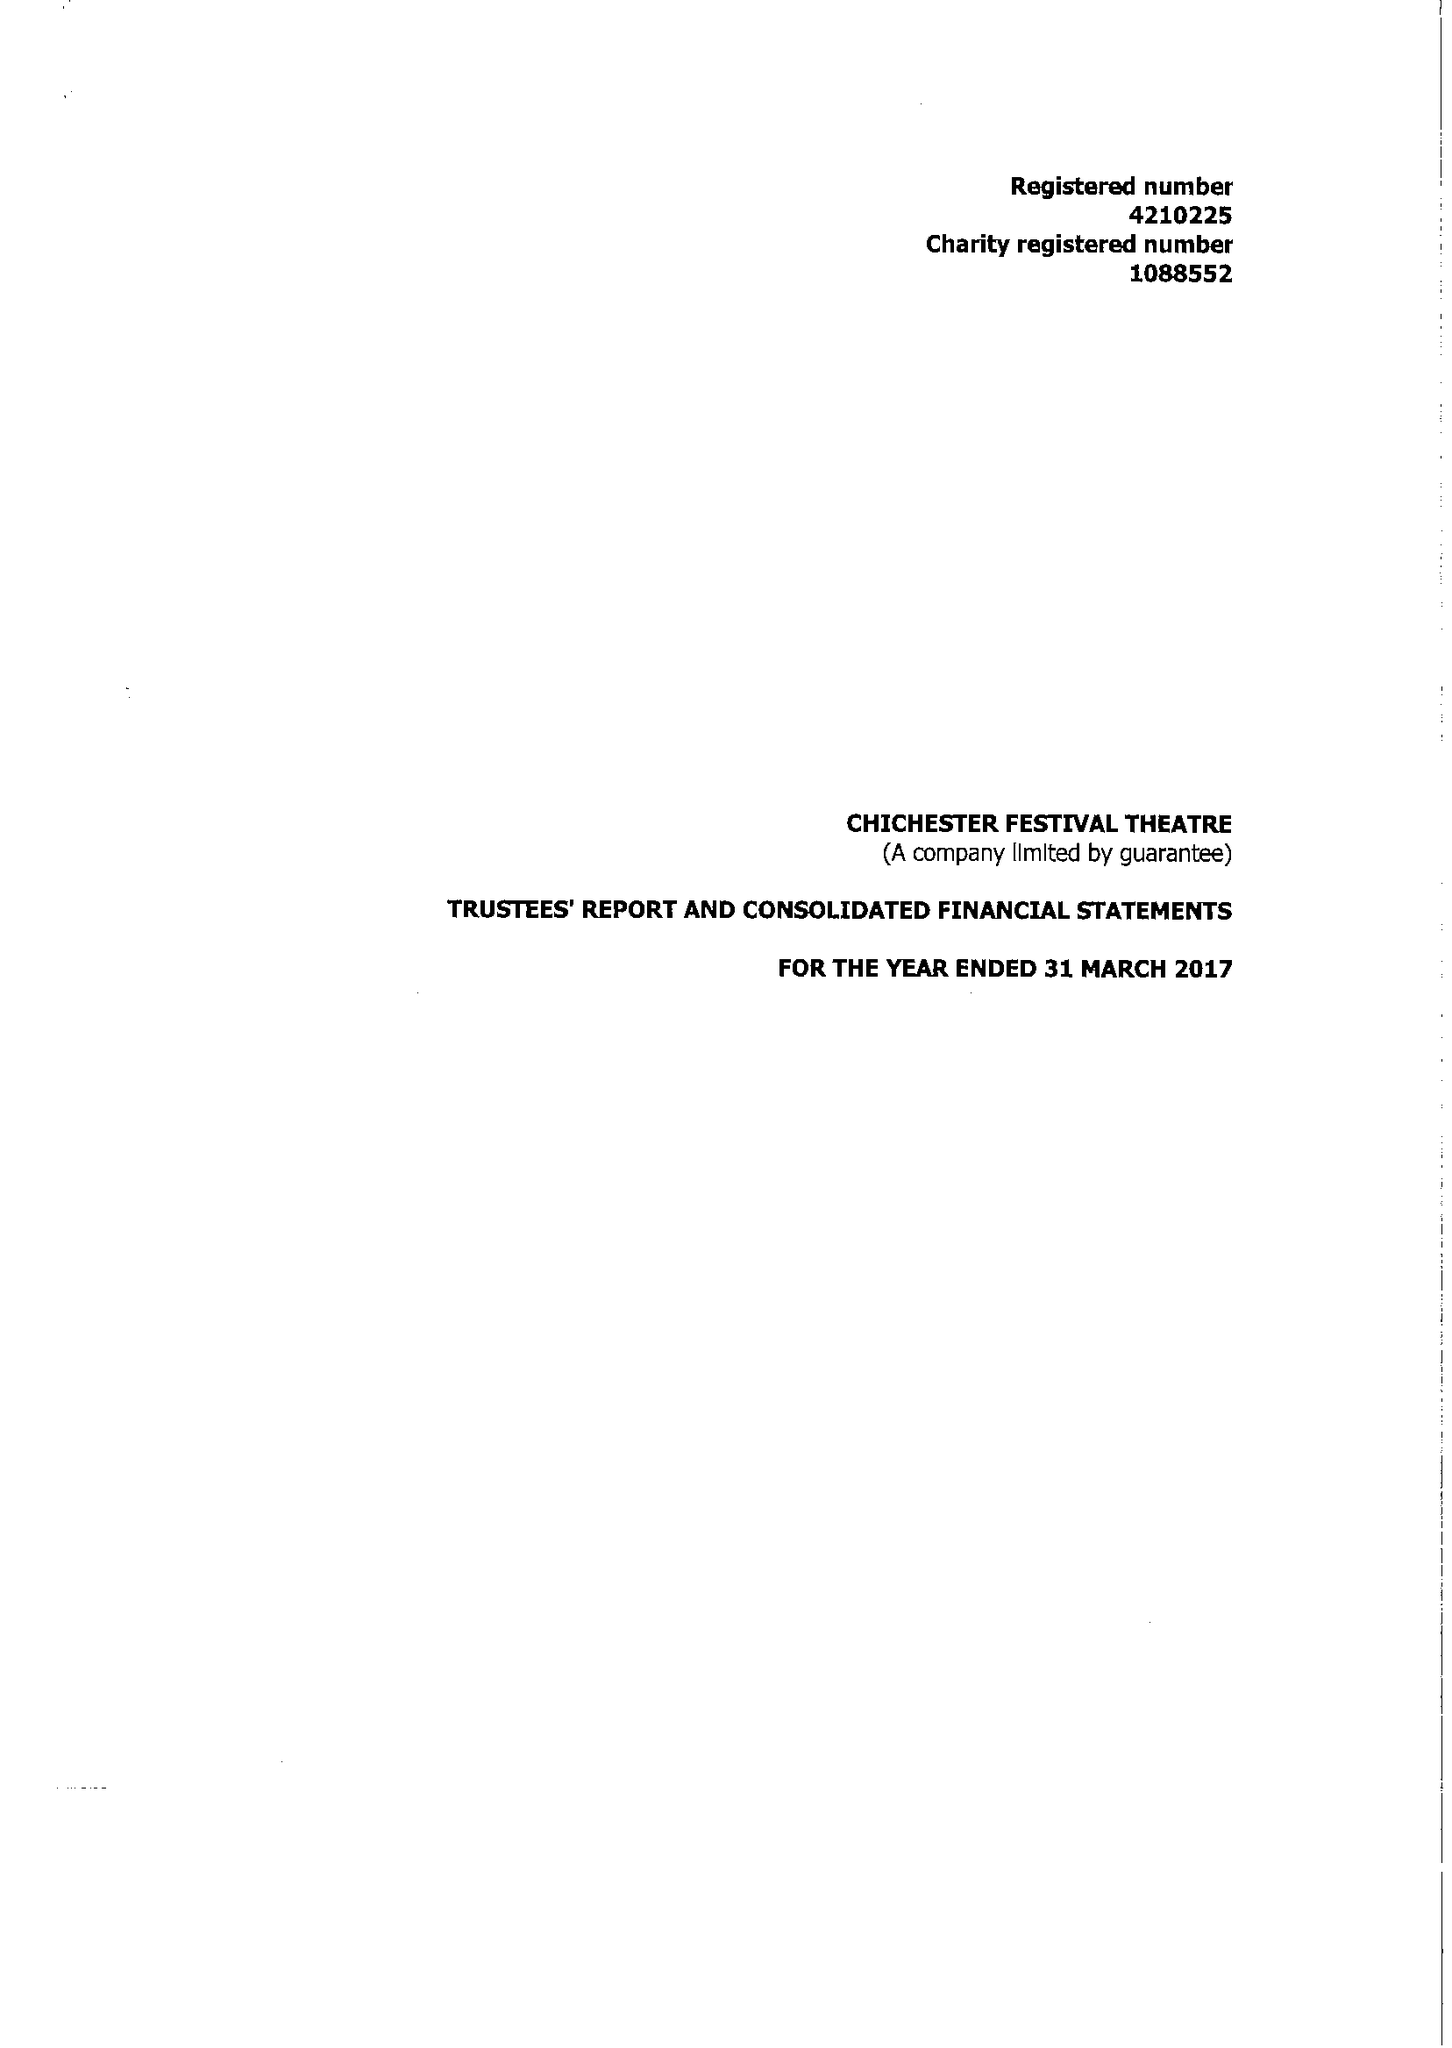What is the value for the charity_number?
Answer the question using a single word or phrase. 1088552 